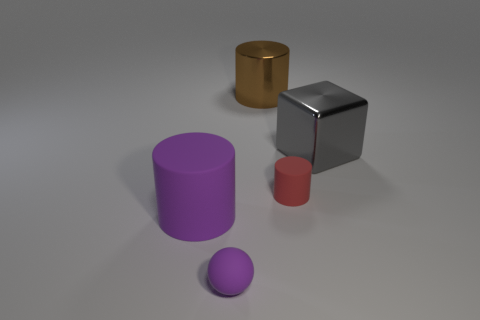Add 3 large cylinders. How many objects exist? 8 Subtract all cylinders. How many objects are left? 2 Subtract all purple balls. Subtract all cyan things. How many objects are left? 4 Add 1 purple cylinders. How many purple cylinders are left? 2 Add 3 large cyan metallic spheres. How many large cyan metallic spheres exist? 3 Subtract 0 blue balls. How many objects are left? 5 